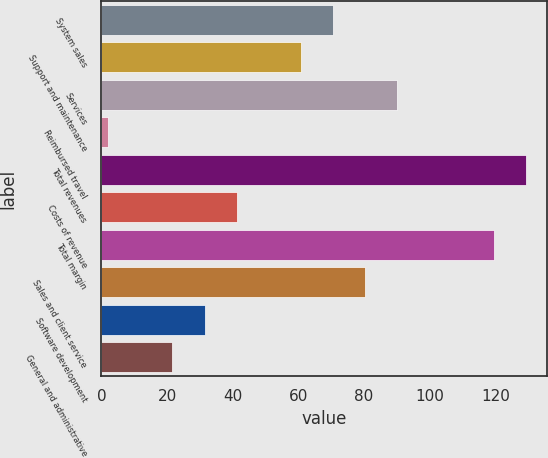<chart> <loc_0><loc_0><loc_500><loc_500><bar_chart><fcel>System sales<fcel>Support and maintenance<fcel>Services<fcel>Reimbursed travel<fcel>Total revenues<fcel>Costs of revenue<fcel>Total margin<fcel>Sales and client service<fcel>Software development<fcel>General and administrative<nl><fcel>70.6<fcel>60.8<fcel>90.2<fcel>2<fcel>129.4<fcel>41.2<fcel>119.6<fcel>80.4<fcel>31.4<fcel>21.6<nl></chart> 